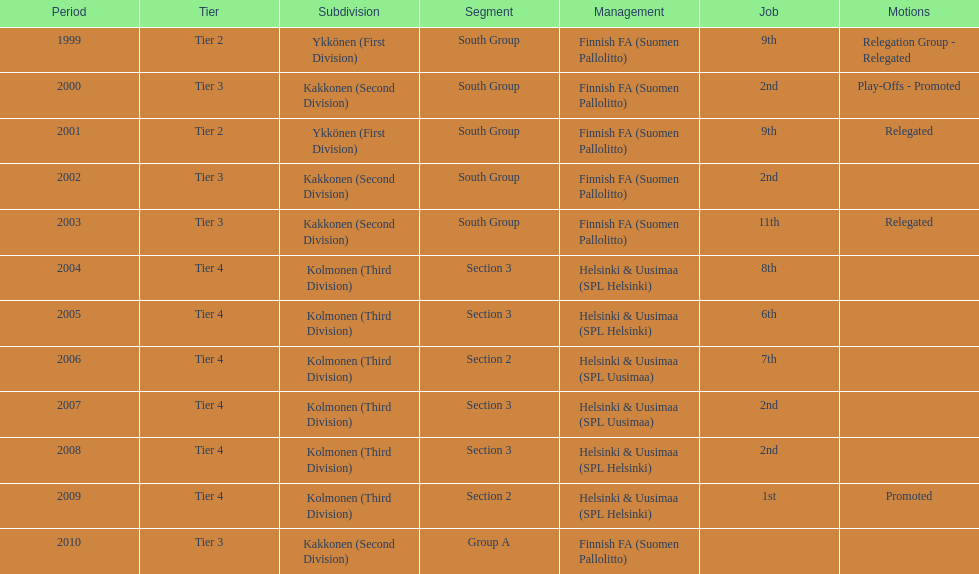I'm looking to parse the entire table for insights. Could you assist me with that? {'header': ['Period', 'Tier', 'Subdivision', 'Segment', 'Management', 'Job', 'Motions'], 'rows': [['1999', 'Tier 2', 'Ykkönen (First Division)', 'South Group', 'Finnish FA (Suomen Pallolitto)', '9th', 'Relegation Group - Relegated'], ['2000', 'Tier 3', 'Kakkonen (Second Division)', 'South Group', 'Finnish FA (Suomen Pallolitto)', '2nd', 'Play-Offs - Promoted'], ['2001', 'Tier 2', 'Ykkönen (First Division)', 'South Group', 'Finnish FA (Suomen Pallolitto)', '9th', 'Relegated'], ['2002', 'Tier 3', 'Kakkonen (Second Division)', 'South Group', 'Finnish FA (Suomen Pallolitto)', '2nd', ''], ['2003', 'Tier 3', 'Kakkonen (Second Division)', 'South Group', 'Finnish FA (Suomen Pallolitto)', '11th', 'Relegated'], ['2004', 'Tier 4', 'Kolmonen (Third Division)', 'Section 3', 'Helsinki & Uusimaa (SPL Helsinki)', '8th', ''], ['2005', 'Tier 4', 'Kolmonen (Third Division)', 'Section 3', 'Helsinki & Uusimaa (SPL Helsinki)', '6th', ''], ['2006', 'Tier 4', 'Kolmonen (Third Division)', 'Section 2', 'Helsinki & Uusimaa (SPL Uusimaa)', '7th', ''], ['2007', 'Tier 4', 'Kolmonen (Third Division)', 'Section 3', 'Helsinki & Uusimaa (SPL Uusimaa)', '2nd', ''], ['2008', 'Tier 4', 'Kolmonen (Third Division)', 'Section 3', 'Helsinki & Uusimaa (SPL Helsinki)', '2nd', ''], ['2009', 'Tier 4', 'Kolmonen (Third Division)', 'Section 2', 'Helsinki & Uusimaa (SPL Helsinki)', '1st', 'Promoted'], ['2010', 'Tier 3', 'Kakkonen (Second Division)', 'Group A', 'Finnish FA (Suomen Pallolitto)', '', '']]} How many times has this team been relegated? 3. 